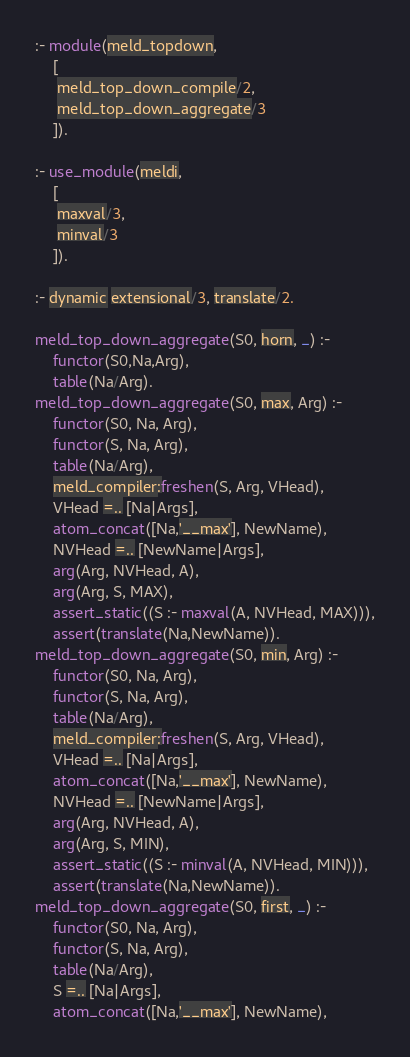Convert code to text. <code><loc_0><loc_0><loc_500><loc_500><_Prolog_>
:- module(meld_topdown,
	[
	 meld_top_down_compile/2,
	 meld_top_down_aggregate/3
	]).

:- use_module(meldi,
	[
	 maxval/3,
	 minval/3
	]).

:- dynamic extensional/3, translate/2.

meld_top_down_aggregate(S0, horn, _) :-
	functor(S0,Na,Arg),
	table(Na/Arg).
meld_top_down_aggregate(S0, max, Arg) :-
	functor(S0, Na, Arg), 
	functor(S, Na, Arg), 
	table(Na/Arg),
	meld_compiler:freshen(S, Arg, VHead),
	VHead =.. [Na|Args],
	atom_concat([Na,'__max'], NewName),
	NVHead =.. [NewName|Args],
	arg(Arg, NVHead, A),
	arg(Arg, S, MAX),
	assert_static((S :- maxval(A, NVHead, MAX))),
	assert(translate(Na,NewName)).
meld_top_down_aggregate(S0, min, Arg) :-
	functor(S0, Na, Arg), 
	functor(S, Na, Arg), 
	table(Na/Arg),
	meld_compiler:freshen(S, Arg, VHead),
	VHead =.. [Na|Args],
	atom_concat([Na,'__max'], NewName),
	NVHead =.. [NewName|Args],
	arg(Arg, NVHead, A),
	arg(Arg, S, MIN),
	assert_static((S :- minval(A, NVHead, MIN))),
	assert(translate(Na,NewName)).	
meld_top_down_aggregate(S0, first, _) :-
	functor(S0, Na, Arg), 
	functor(S, Na, Arg), 
	table(Na/Arg),
	S =.. [Na|Args],
	atom_concat([Na,'__max'], NewName),</code> 